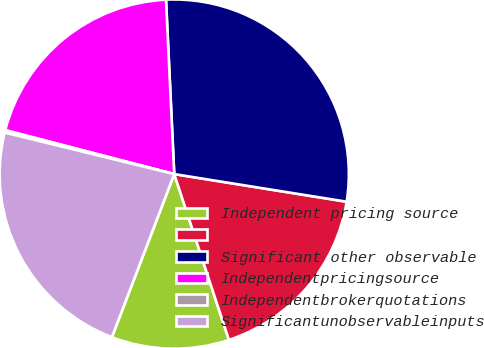Convert chart. <chart><loc_0><loc_0><loc_500><loc_500><pie_chart><fcel>Independent pricing source<fcel>Unnamed: 1<fcel>Significant other observable<fcel>Independentpricingsource<fcel>Independentbrokerquotations<fcel>Significantunobservableinputs<nl><fcel>10.88%<fcel>17.4%<fcel>28.28%<fcel>20.2%<fcel>0.23%<fcel>23.01%<nl></chart> 